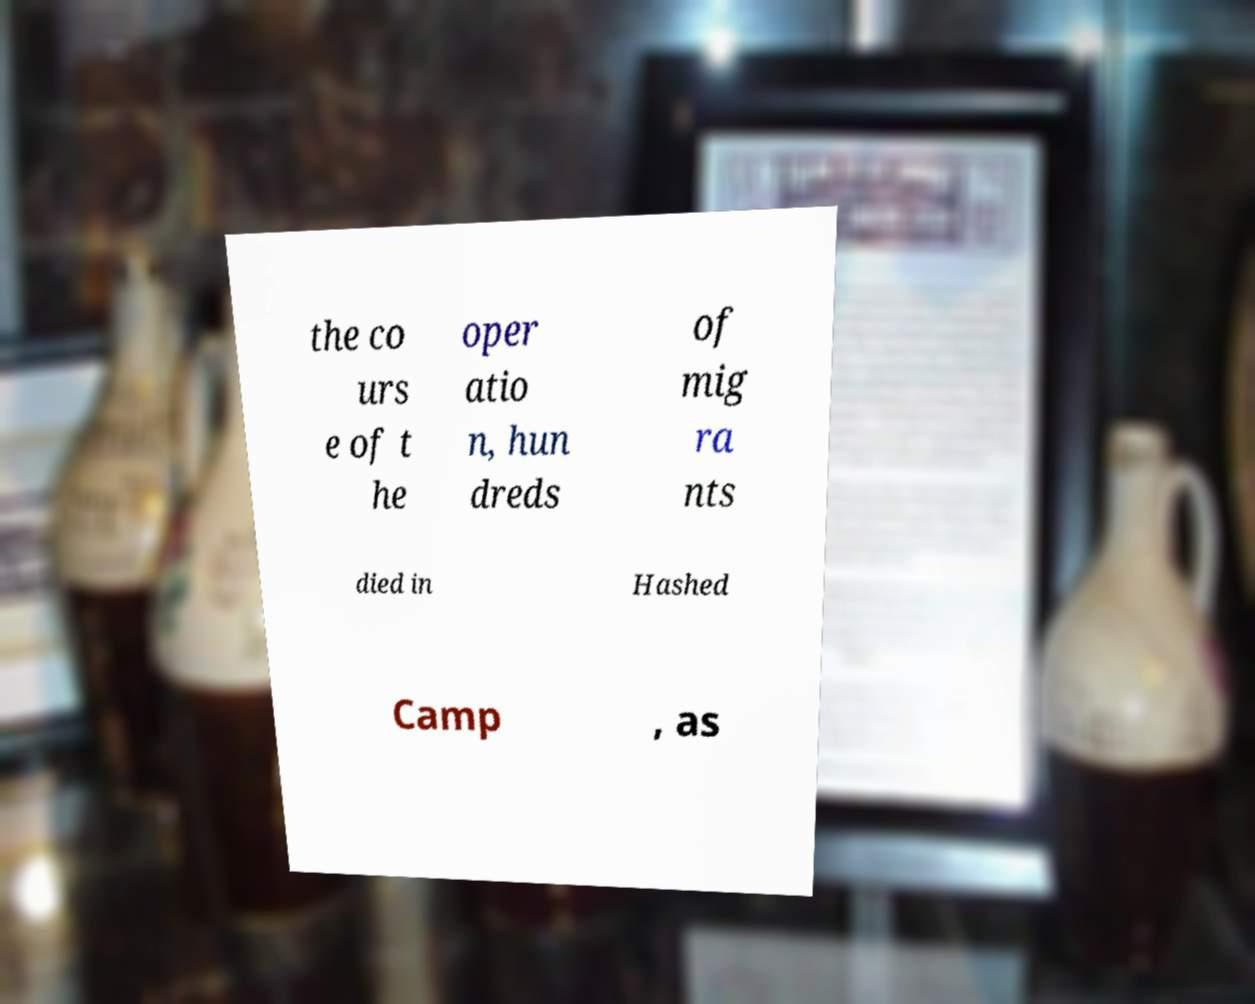Please identify and transcribe the text found in this image. the co urs e of t he oper atio n, hun dreds of mig ra nts died in Hashed Camp , as 